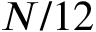<formula> <loc_0><loc_0><loc_500><loc_500>N / 1 2</formula> 